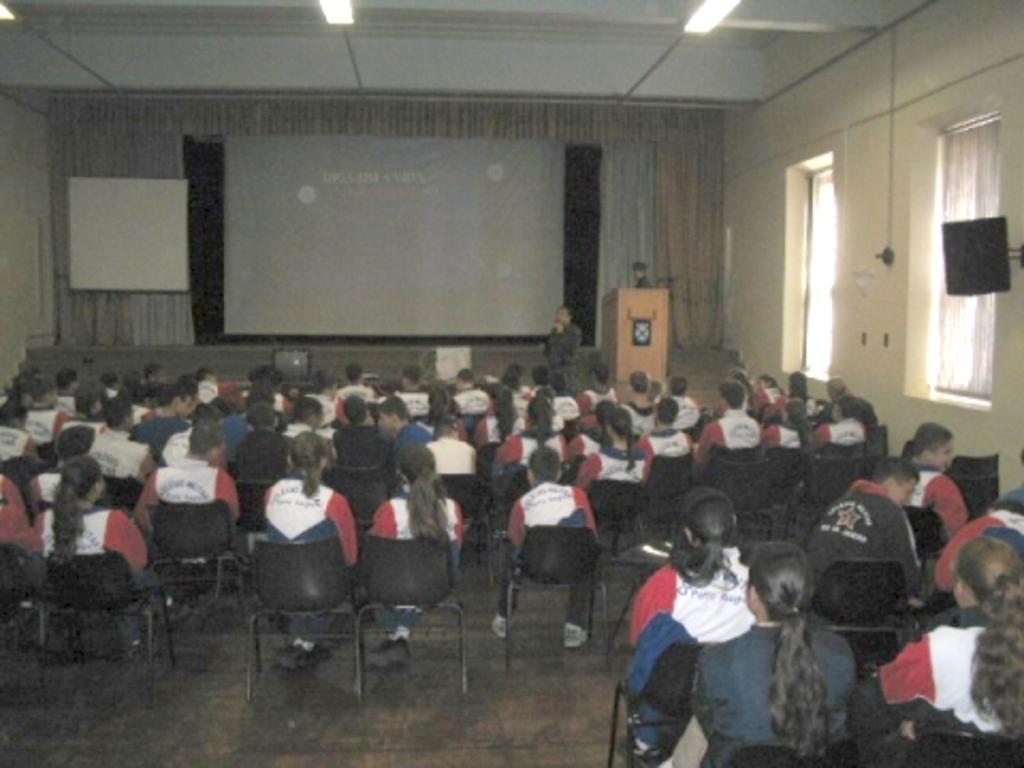How would you summarize this image in a sentence or two? In this image There are people, chairs in the foreground. There is a floor at the bottom. There are walls, windows and television in the right corner. There is a curtain in the background. There are lights on roof at the top. 